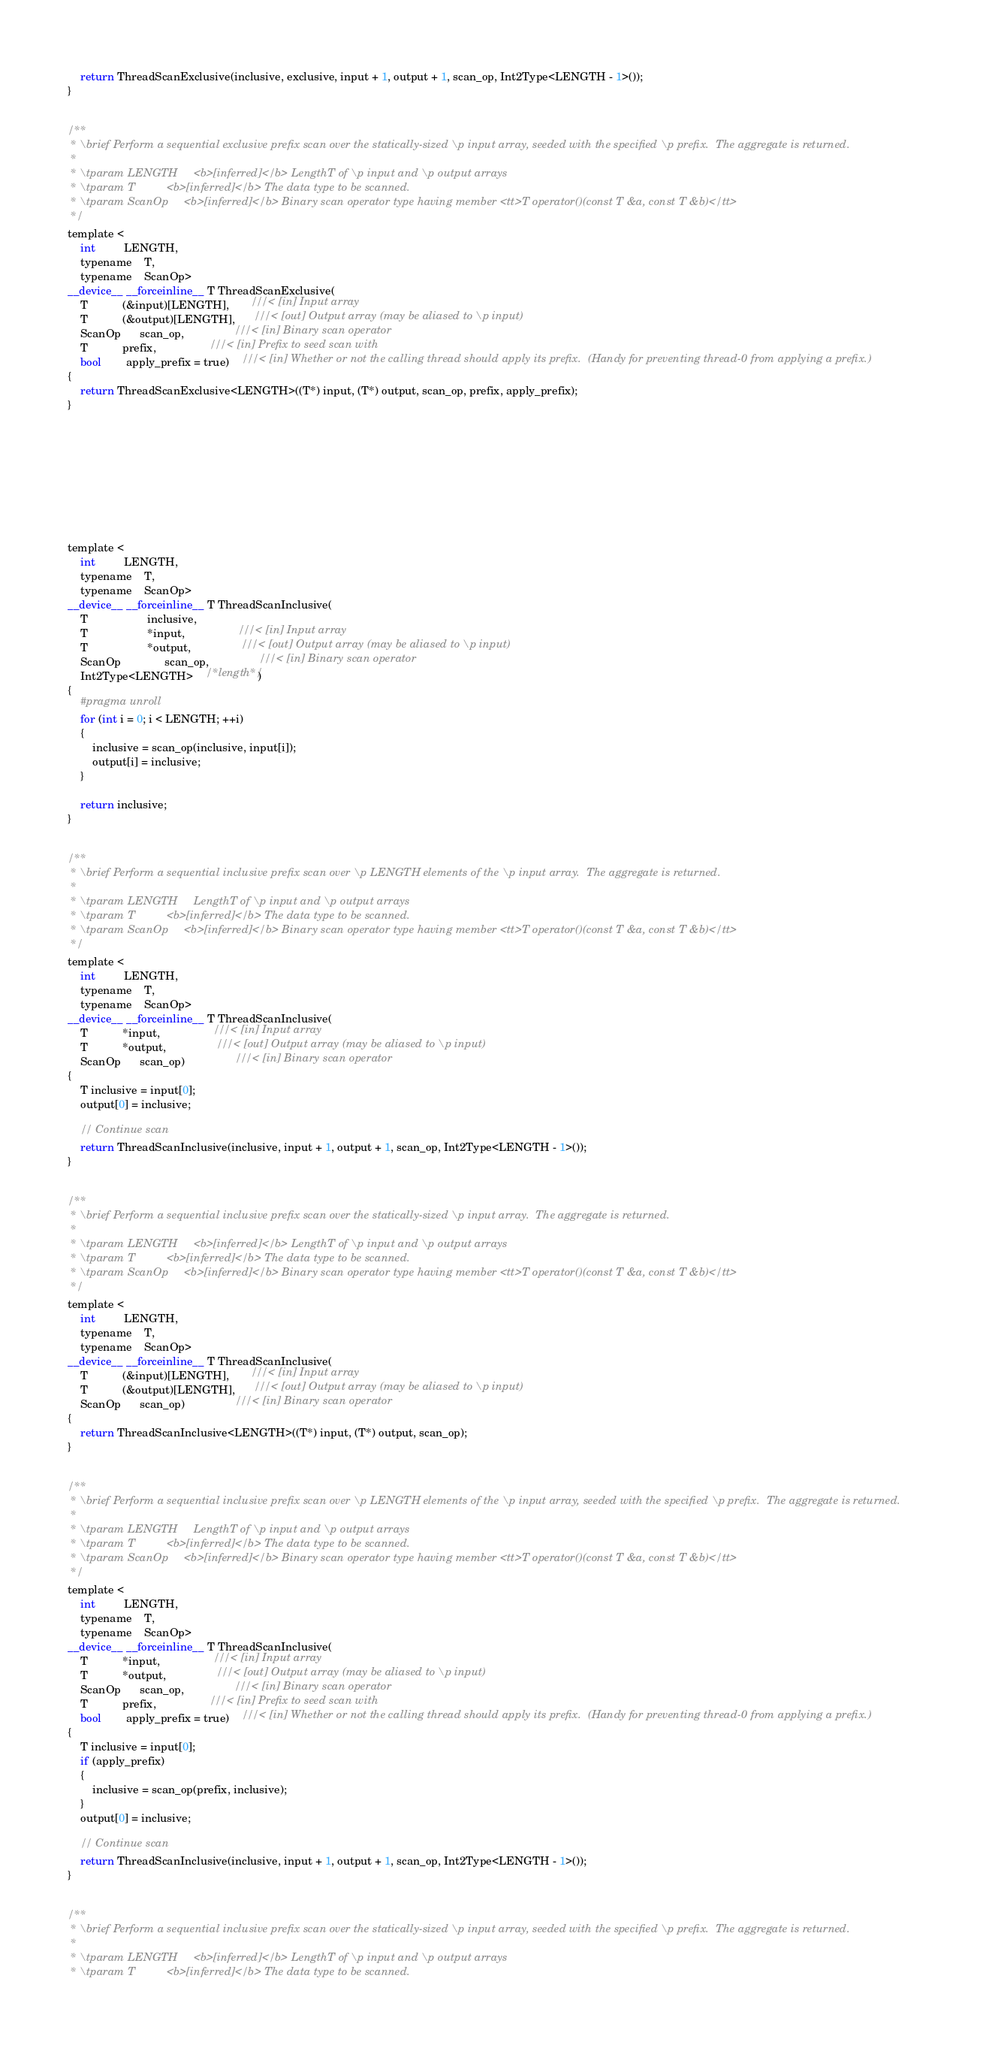<code> <loc_0><loc_0><loc_500><loc_500><_Cuda_>
    return ThreadScanExclusive(inclusive, exclusive, input + 1, output + 1, scan_op, Int2Type<LENGTH - 1>());
}


/**
 * \brief Perform a sequential exclusive prefix scan over the statically-sized \p input array, seeded with the specified \p prefix.  The aggregate is returned.
 *
 * \tparam LENGTH     <b>[inferred]</b> LengthT of \p input and \p output arrays
 * \tparam T          <b>[inferred]</b> The data type to be scanned.
 * \tparam ScanOp     <b>[inferred]</b> Binary scan operator type having member <tt>T operator()(const T &a, const T &b)</tt>
 */
template <
    int         LENGTH,
    typename    T,
    typename    ScanOp>
__device__ __forceinline__ T ThreadScanExclusive(
    T           (&input)[LENGTH],       ///< [in] Input array
    T           (&output)[LENGTH],      ///< [out] Output array (may be aliased to \p input)
    ScanOp      scan_op,                ///< [in] Binary scan operator
    T           prefix,                 ///< [in] Prefix to seed scan with
    bool        apply_prefix = true)    ///< [in] Whether or not the calling thread should apply its prefix.  (Handy for preventing thread-0 from applying a prefix.)
{
    return ThreadScanExclusive<LENGTH>((T*) input, (T*) output, scan_op, prefix, apply_prefix);
}









template <
    int         LENGTH,
    typename    T,
    typename    ScanOp>
__device__ __forceinline__ T ThreadScanInclusive(
    T                   inclusive,
    T                   *input,                 ///< [in] Input array
    T                   *output,                ///< [out] Output array (may be aliased to \p input)
    ScanOp              scan_op,                ///< [in] Binary scan operator
    Int2Type<LENGTH>    /*length*/)
{
    #pragma unroll
    for (int i = 0; i < LENGTH; ++i)
    {
        inclusive = scan_op(inclusive, input[i]);
        output[i] = inclusive;
    }

    return inclusive;
}


/**
 * \brief Perform a sequential inclusive prefix scan over \p LENGTH elements of the \p input array.  The aggregate is returned.
 *
 * \tparam LENGTH     LengthT of \p input and \p output arrays
 * \tparam T          <b>[inferred]</b> The data type to be scanned.
 * \tparam ScanOp     <b>[inferred]</b> Binary scan operator type having member <tt>T operator()(const T &a, const T &b)</tt>
 */
template <
    int         LENGTH,
    typename    T,
    typename    ScanOp>
__device__ __forceinline__ T ThreadScanInclusive(
    T           *input,                 ///< [in] Input array
    T           *output,                ///< [out] Output array (may be aliased to \p input)
    ScanOp      scan_op)                ///< [in] Binary scan operator
{
    T inclusive = input[0];
    output[0] = inclusive;

    // Continue scan
    return ThreadScanInclusive(inclusive, input + 1, output + 1, scan_op, Int2Type<LENGTH - 1>());
}


/**
 * \brief Perform a sequential inclusive prefix scan over the statically-sized \p input array.  The aggregate is returned.
 *
 * \tparam LENGTH     <b>[inferred]</b> LengthT of \p input and \p output arrays
 * \tparam T          <b>[inferred]</b> The data type to be scanned.
 * \tparam ScanOp     <b>[inferred]</b> Binary scan operator type having member <tt>T operator()(const T &a, const T &b)</tt>
 */
template <
    int         LENGTH,
    typename    T,
    typename    ScanOp>
__device__ __forceinline__ T ThreadScanInclusive(
    T           (&input)[LENGTH],       ///< [in] Input array
    T           (&output)[LENGTH],      ///< [out] Output array (may be aliased to \p input)
    ScanOp      scan_op)                ///< [in] Binary scan operator
{
    return ThreadScanInclusive<LENGTH>((T*) input, (T*) output, scan_op);
}


/**
 * \brief Perform a sequential inclusive prefix scan over \p LENGTH elements of the \p input array, seeded with the specified \p prefix.  The aggregate is returned.
 *
 * \tparam LENGTH     LengthT of \p input and \p output arrays
 * \tparam T          <b>[inferred]</b> The data type to be scanned.
 * \tparam ScanOp     <b>[inferred]</b> Binary scan operator type having member <tt>T operator()(const T &a, const T &b)</tt>
 */
template <
    int         LENGTH,
    typename    T,
    typename    ScanOp>
__device__ __forceinline__ T ThreadScanInclusive(
    T           *input,                 ///< [in] Input array
    T           *output,                ///< [out] Output array (may be aliased to \p input)
    ScanOp      scan_op,                ///< [in] Binary scan operator
    T           prefix,                 ///< [in] Prefix to seed scan with
    bool        apply_prefix = true)    ///< [in] Whether or not the calling thread should apply its prefix.  (Handy for preventing thread-0 from applying a prefix.)
{
    T inclusive = input[0];
    if (apply_prefix)
    {
        inclusive = scan_op(prefix, inclusive);
    }
    output[0] = inclusive;

    // Continue scan
    return ThreadScanInclusive(inclusive, input + 1, output + 1, scan_op, Int2Type<LENGTH - 1>());
}


/**
 * \brief Perform a sequential inclusive prefix scan over the statically-sized \p input array, seeded with the specified \p prefix.  The aggregate is returned.
 *
 * \tparam LENGTH     <b>[inferred]</b> LengthT of \p input and \p output arrays
 * \tparam T          <b>[inferred]</b> The data type to be scanned.</code> 